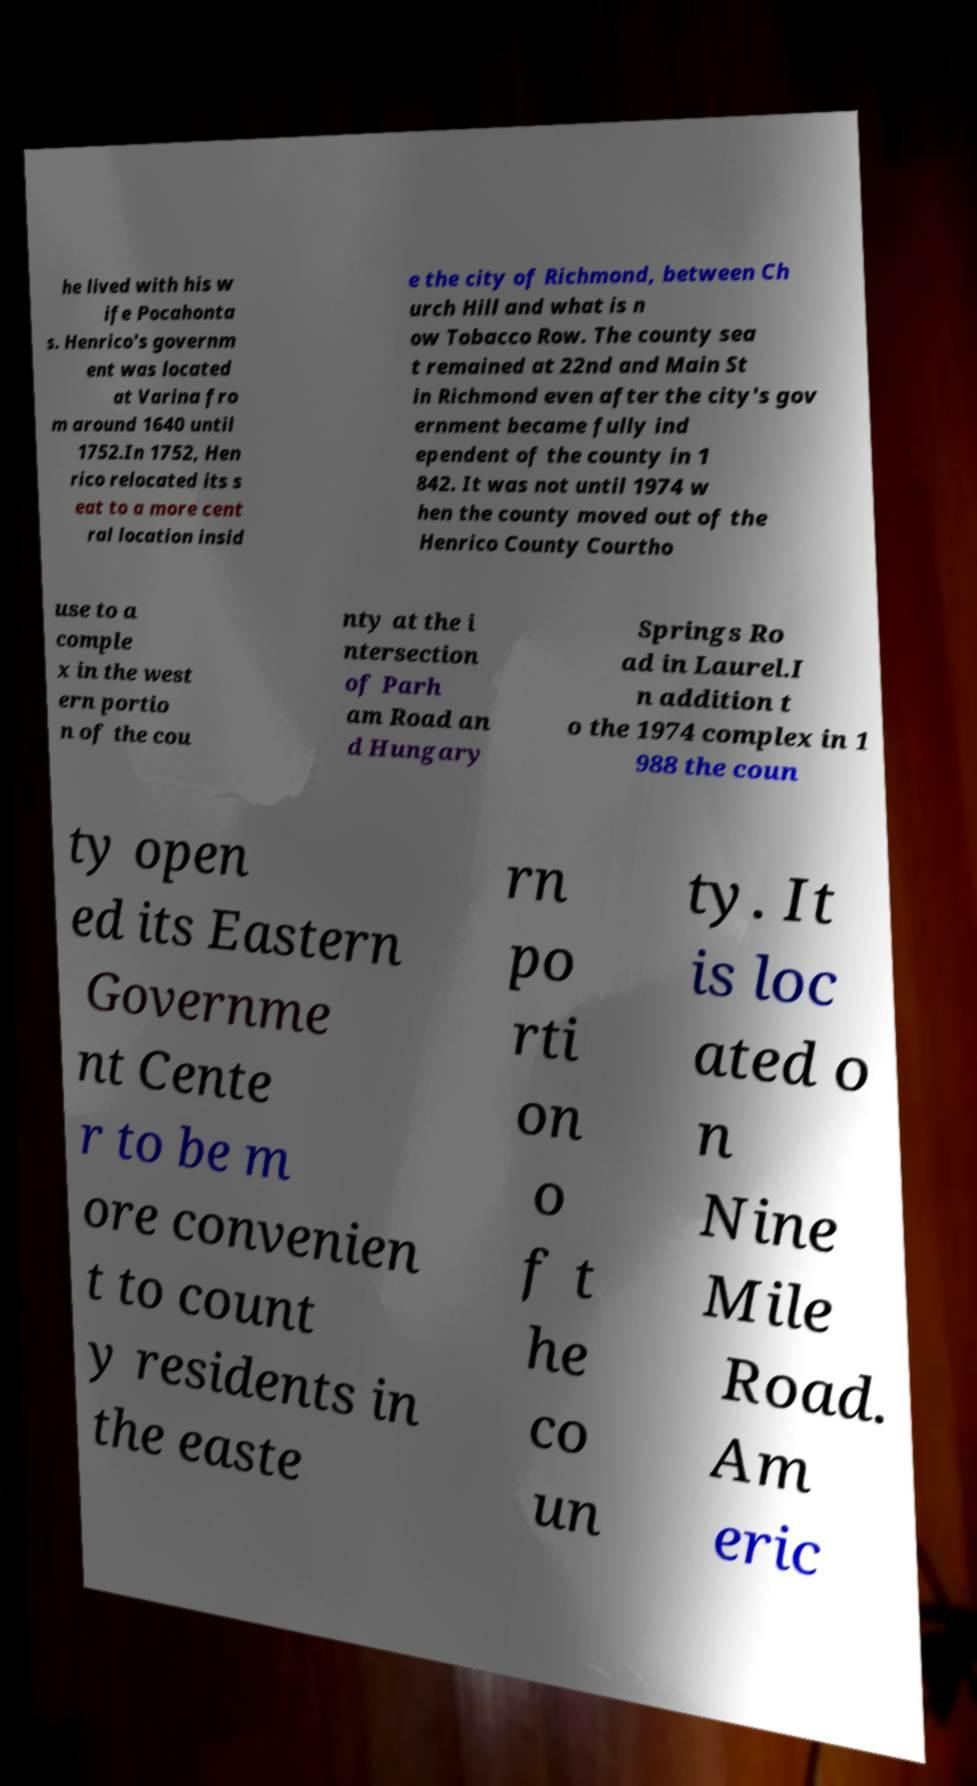Please read and relay the text visible in this image. What does it say? he lived with his w ife Pocahonta s. Henrico's governm ent was located at Varina fro m around 1640 until 1752.In 1752, Hen rico relocated its s eat to a more cent ral location insid e the city of Richmond, between Ch urch Hill and what is n ow Tobacco Row. The county sea t remained at 22nd and Main St in Richmond even after the city's gov ernment became fully ind ependent of the county in 1 842. It was not until 1974 w hen the county moved out of the Henrico County Courtho use to a comple x in the west ern portio n of the cou nty at the i ntersection of Parh am Road an d Hungary Springs Ro ad in Laurel.I n addition t o the 1974 complex in 1 988 the coun ty open ed its Eastern Governme nt Cente r to be m ore convenien t to count y residents in the easte rn po rti on o f t he co un ty. It is loc ated o n Nine Mile Road. Am eric 